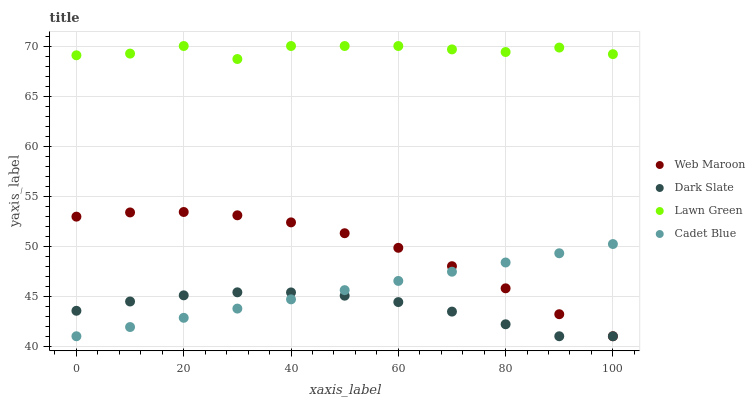Does Dark Slate have the minimum area under the curve?
Answer yes or no. Yes. Does Lawn Green have the maximum area under the curve?
Answer yes or no. Yes. Does Cadet Blue have the minimum area under the curve?
Answer yes or no. No. Does Cadet Blue have the maximum area under the curve?
Answer yes or no. No. Is Cadet Blue the smoothest?
Answer yes or no. Yes. Is Lawn Green the roughest?
Answer yes or no. Yes. Is Web Maroon the smoothest?
Answer yes or no. No. Is Web Maroon the roughest?
Answer yes or no. No. Does Dark Slate have the lowest value?
Answer yes or no. Yes. Does Lawn Green have the lowest value?
Answer yes or no. No. Does Lawn Green have the highest value?
Answer yes or no. Yes. Does Cadet Blue have the highest value?
Answer yes or no. No. Is Cadet Blue less than Lawn Green?
Answer yes or no. Yes. Is Lawn Green greater than Cadet Blue?
Answer yes or no. Yes. Does Cadet Blue intersect Dark Slate?
Answer yes or no. Yes. Is Cadet Blue less than Dark Slate?
Answer yes or no. No. Is Cadet Blue greater than Dark Slate?
Answer yes or no. No. Does Cadet Blue intersect Lawn Green?
Answer yes or no. No. 